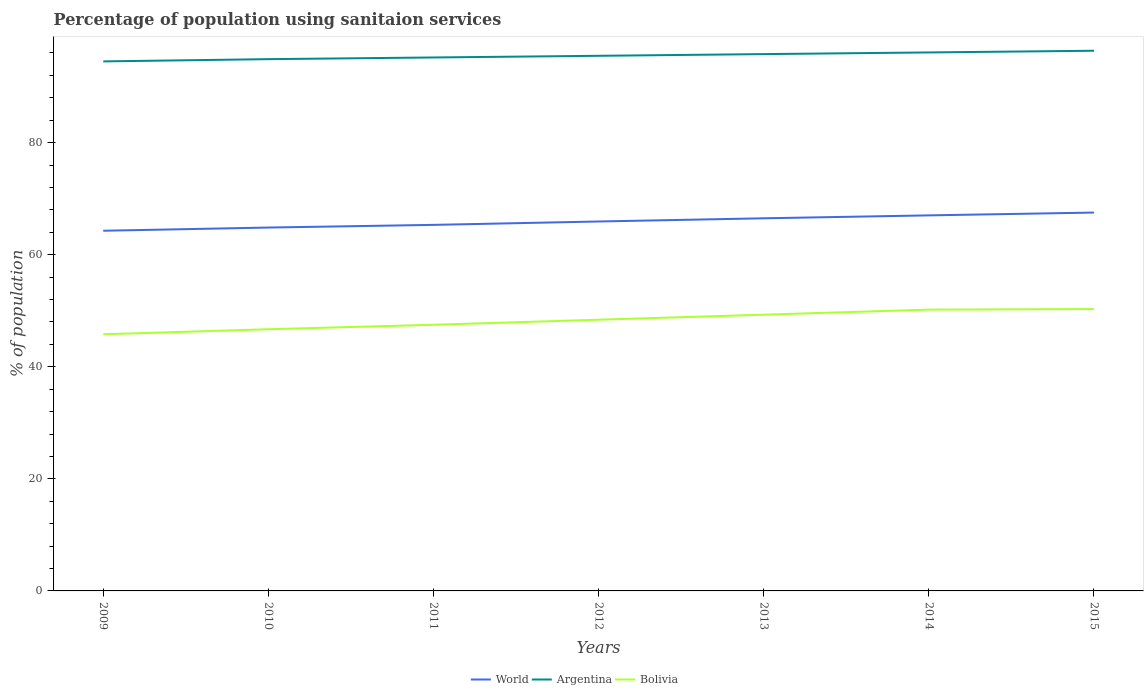How many different coloured lines are there?
Offer a very short reply. 3. Does the line corresponding to Bolivia intersect with the line corresponding to Argentina?
Your answer should be compact. No. Across all years, what is the maximum percentage of population using sanitaion services in Bolivia?
Offer a terse response. 45.8. In which year was the percentage of population using sanitaion services in Argentina maximum?
Offer a very short reply. 2009. What is the total percentage of population using sanitaion services in World in the graph?
Keep it short and to the point. -0.57. What is the difference between the highest and the second highest percentage of population using sanitaion services in World?
Your answer should be very brief. 3.25. What is the difference between the highest and the lowest percentage of population using sanitaion services in World?
Provide a succinct answer. 4. Are the values on the major ticks of Y-axis written in scientific E-notation?
Ensure brevity in your answer.  No. Does the graph contain any zero values?
Your response must be concise. No. Does the graph contain grids?
Give a very brief answer. No. How many legend labels are there?
Make the answer very short. 3. What is the title of the graph?
Your answer should be compact. Percentage of population using sanitaion services. Does "Tajikistan" appear as one of the legend labels in the graph?
Give a very brief answer. No. What is the label or title of the Y-axis?
Your answer should be compact. % of population. What is the % of population of World in 2009?
Offer a very short reply. 64.28. What is the % of population of Argentina in 2009?
Offer a terse response. 94.5. What is the % of population of Bolivia in 2009?
Make the answer very short. 45.8. What is the % of population in World in 2010?
Give a very brief answer. 64.85. What is the % of population in Argentina in 2010?
Keep it short and to the point. 94.9. What is the % of population in Bolivia in 2010?
Your response must be concise. 46.7. What is the % of population in World in 2011?
Your answer should be very brief. 65.33. What is the % of population of Argentina in 2011?
Keep it short and to the point. 95.2. What is the % of population of Bolivia in 2011?
Offer a very short reply. 47.5. What is the % of population of World in 2012?
Keep it short and to the point. 65.93. What is the % of population in Argentina in 2012?
Offer a very short reply. 95.5. What is the % of population in Bolivia in 2012?
Offer a terse response. 48.4. What is the % of population of World in 2013?
Provide a succinct answer. 66.5. What is the % of population in Argentina in 2013?
Provide a short and direct response. 95.8. What is the % of population of Bolivia in 2013?
Keep it short and to the point. 49.3. What is the % of population of World in 2014?
Your answer should be very brief. 67.02. What is the % of population in Argentina in 2014?
Your answer should be very brief. 96.1. What is the % of population in Bolivia in 2014?
Your answer should be very brief. 50.2. What is the % of population in World in 2015?
Make the answer very short. 67.52. What is the % of population of Argentina in 2015?
Offer a terse response. 96.4. What is the % of population of Bolivia in 2015?
Your answer should be very brief. 50.3. Across all years, what is the maximum % of population of World?
Give a very brief answer. 67.52. Across all years, what is the maximum % of population of Argentina?
Give a very brief answer. 96.4. Across all years, what is the maximum % of population in Bolivia?
Your response must be concise. 50.3. Across all years, what is the minimum % of population in World?
Keep it short and to the point. 64.28. Across all years, what is the minimum % of population of Argentina?
Offer a terse response. 94.5. Across all years, what is the minimum % of population in Bolivia?
Provide a short and direct response. 45.8. What is the total % of population of World in the graph?
Ensure brevity in your answer.  461.43. What is the total % of population in Argentina in the graph?
Your response must be concise. 668.4. What is the total % of population of Bolivia in the graph?
Give a very brief answer. 338.2. What is the difference between the % of population of World in 2009 and that in 2010?
Your answer should be compact. -0.57. What is the difference between the % of population of Bolivia in 2009 and that in 2010?
Give a very brief answer. -0.9. What is the difference between the % of population of World in 2009 and that in 2011?
Keep it short and to the point. -1.05. What is the difference between the % of population in World in 2009 and that in 2012?
Your response must be concise. -1.65. What is the difference between the % of population of Argentina in 2009 and that in 2012?
Ensure brevity in your answer.  -1. What is the difference between the % of population in World in 2009 and that in 2013?
Provide a succinct answer. -2.22. What is the difference between the % of population of World in 2009 and that in 2014?
Offer a terse response. -2.74. What is the difference between the % of population of Argentina in 2009 and that in 2014?
Your answer should be compact. -1.6. What is the difference between the % of population in World in 2009 and that in 2015?
Give a very brief answer. -3.25. What is the difference between the % of population of Argentina in 2009 and that in 2015?
Make the answer very short. -1.9. What is the difference between the % of population of World in 2010 and that in 2011?
Your answer should be compact. -0.48. What is the difference between the % of population in Argentina in 2010 and that in 2011?
Provide a succinct answer. -0.3. What is the difference between the % of population in World in 2010 and that in 2012?
Your answer should be compact. -1.08. What is the difference between the % of population of Argentina in 2010 and that in 2012?
Provide a short and direct response. -0.6. What is the difference between the % of population in Bolivia in 2010 and that in 2012?
Give a very brief answer. -1.7. What is the difference between the % of population in World in 2010 and that in 2013?
Your response must be concise. -1.65. What is the difference between the % of population in World in 2010 and that in 2014?
Your answer should be very brief. -2.17. What is the difference between the % of population in Argentina in 2010 and that in 2014?
Keep it short and to the point. -1.2. What is the difference between the % of population of Bolivia in 2010 and that in 2014?
Keep it short and to the point. -3.5. What is the difference between the % of population in World in 2010 and that in 2015?
Your response must be concise. -2.67. What is the difference between the % of population in Bolivia in 2010 and that in 2015?
Provide a short and direct response. -3.6. What is the difference between the % of population of World in 2011 and that in 2012?
Offer a very short reply. -0.6. What is the difference between the % of population in Bolivia in 2011 and that in 2012?
Make the answer very short. -0.9. What is the difference between the % of population of World in 2011 and that in 2013?
Keep it short and to the point. -1.17. What is the difference between the % of population of Argentina in 2011 and that in 2013?
Offer a very short reply. -0.6. What is the difference between the % of population of World in 2011 and that in 2014?
Provide a succinct answer. -1.7. What is the difference between the % of population of World in 2011 and that in 2015?
Your answer should be very brief. -2.2. What is the difference between the % of population in World in 2012 and that in 2013?
Give a very brief answer. -0.57. What is the difference between the % of population in Argentina in 2012 and that in 2013?
Give a very brief answer. -0.3. What is the difference between the % of population in Bolivia in 2012 and that in 2013?
Offer a terse response. -0.9. What is the difference between the % of population of World in 2012 and that in 2014?
Your answer should be compact. -1.09. What is the difference between the % of population of Argentina in 2012 and that in 2014?
Offer a very short reply. -0.6. What is the difference between the % of population in Bolivia in 2012 and that in 2014?
Offer a terse response. -1.8. What is the difference between the % of population of World in 2012 and that in 2015?
Provide a succinct answer. -1.59. What is the difference between the % of population in Argentina in 2012 and that in 2015?
Ensure brevity in your answer.  -0.9. What is the difference between the % of population of Bolivia in 2012 and that in 2015?
Offer a very short reply. -1.9. What is the difference between the % of population in World in 2013 and that in 2014?
Your response must be concise. -0.52. What is the difference between the % of population in World in 2013 and that in 2015?
Make the answer very short. -1.02. What is the difference between the % of population in Argentina in 2013 and that in 2015?
Offer a very short reply. -0.6. What is the difference between the % of population of World in 2014 and that in 2015?
Offer a very short reply. -0.5. What is the difference between the % of population of Bolivia in 2014 and that in 2015?
Make the answer very short. -0.1. What is the difference between the % of population in World in 2009 and the % of population in Argentina in 2010?
Your response must be concise. -30.62. What is the difference between the % of population in World in 2009 and the % of population in Bolivia in 2010?
Keep it short and to the point. 17.58. What is the difference between the % of population in Argentina in 2009 and the % of population in Bolivia in 2010?
Keep it short and to the point. 47.8. What is the difference between the % of population of World in 2009 and the % of population of Argentina in 2011?
Your answer should be compact. -30.92. What is the difference between the % of population in World in 2009 and the % of population in Bolivia in 2011?
Provide a succinct answer. 16.78. What is the difference between the % of population in Argentina in 2009 and the % of population in Bolivia in 2011?
Provide a succinct answer. 47. What is the difference between the % of population of World in 2009 and the % of population of Argentina in 2012?
Provide a succinct answer. -31.22. What is the difference between the % of population of World in 2009 and the % of population of Bolivia in 2012?
Offer a very short reply. 15.88. What is the difference between the % of population of Argentina in 2009 and the % of population of Bolivia in 2012?
Offer a terse response. 46.1. What is the difference between the % of population of World in 2009 and the % of population of Argentina in 2013?
Your response must be concise. -31.52. What is the difference between the % of population in World in 2009 and the % of population in Bolivia in 2013?
Offer a terse response. 14.98. What is the difference between the % of population of Argentina in 2009 and the % of population of Bolivia in 2013?
Ensure brevity in your answer.  45.2. What is the difference between the % of population of World in 2009 and the % of population of Argentina in 2014?
Provide a succinct answer. -31.82. What is the difference between the % of population in World in 2009 and the % of population in Bolivia in 2014?
Make the answer very short. 14.08. What is the difference between the % of population of Argentina in 2009 and the % of population of Bolivia in 2014?
Make the answer very short. 44.3. What is the difference between the % of population in World in 2009 and the % of population in Argentina in 2015?
Provide a succinct answer. -32.12. What is the difference between the % of population in World in 2009 and the % of population in Bolivia in 2015?
Provide a short and direct response. 13.98. What is the difference between the % of population of Argentina in 2009 and the % of population of Bolivia in 2015?
Your response must be concise. 44.2. What is the difference between the % of population in World in 2010 and the % of population in Argentina in 2011?
Ensure brevity in your answer.  -30.35. What is the difference between the % of population of World in 2010 and the % of population of Bolivia in 2011?
Give a very brief answer. 17.35. What is the difference between the % of population of Argentina in 2010 and the % of population of Bolivia in 2011?
Offer a very short reply. 47.4. What is the difference between the % of population of World in 2010 and the % of population of Argentina in 2012?
Give a very brief answer. -30.65. What is the difference between the % of population of World in 2010 and the % of population of Bolivia in 2012?
Your answer should be compact. 16.45. What is the difference between the % of population in Argentina in 2010 and the % of population in Bolivia in 2012?
Give a very brief answer. 46.5. What is the difference between the % of population in World in 2010 and the % of population in Argentina in 2013?
Keep it short and to the point. -30.95. What is the difference between the % of population in World in 2010 and the % of population in Bolivia in 2013?
Make the answer very short. 15.55. What is the difference between the % of population in Argentina in 2010 and the % of population in Bolivia in 2013?
Your answer should be very brief. 45.6. What is the difference between the % of population of World in 2010 and the % of population of Argentina in 2014?
Provide a short and direct response. -31.25. What is the difference between the % of population in World in 2010 and the % of population in Bolivia in 2014?
Offer a terse response. 14.65. What is the difference between the % of population in Argentina in 2010 and the % of population in Bolivia in 2014?
Give a very brief answer. 44.7. What is the difference between the % of population in World in 2010 and the % of population in Argentina in 2015?
Offer a terse response. -31.55. What is the difference between the % of population in World in 2010 and the % of population in Bolivia in 2015?
Keep it short and to the point. 14.55. What is the difference between the % of population of Argentina in 2010 and the % of population of Bolivia in 2015?
Your answer should be very brief. 44.6. What is the difference between the % of population of World in 2011 and the % of population of Argentina in 2012?
Offer a very short reply. -30.17. What is the difference between the % of population of World in 2011 and the % of population of Bolivia in 2012?
Offer a very short reply. 16.93. What is the difference between the % of population of Argentina in 2011 and the % of population of Bolivia in 2012?
Your answer should be very brief. 46.8. What is the difference between the % of population of World in 2011 and the % of population of Argentina in 2013?
Provide a short and direct response. -30.47. What is the difference between the % of population in World in 2011 and the % of population in Bolivia in 2013?
Make the answer very short. 16.03. What is the difference between the % of population in Argentina in 2011 and the % of population in Bolivia in 2013?
Make the answer very short. 45.9. What is the difference between the % of population of World in 2011 and the % of population of Argentina in 2014?
Your answer should be compact. -30.77. What is the difference between the % of population of World in 2011 and the % of population of Bolivia in 2014?
Your answer should be compact. 15.13. What is the difference between the % of population in World in 2011 and the % of population in Argentina in 2015?
Give a very brief answer. -31.07. What is the difference between the % of population of World in 2011 and the % of population of Bolivia in 2015?
Offer a very short reply. 15.03. What is the difference between the % of population in Argentina in 2011 and the % of population in Bolivia in 2015?
Provide a short and direct response. 44.9. What is the difference between the % of population in World in 2012 and the % of population in Argentina in 2013?
Your answer should be very brief. -29.87. What is the difference between the % of population of World in 2012 and the % of population of Bolivia in 2013?
Your response must be concise. 16.63. What is the difference between the % of population of Argentina in 2012 and the % of population of Bolivia in 2013?
Give a very brief answer. 46.2. What is the difference between the % of population of World in 2012 and the % of population of Argentina in 2014?
Provide a succinct answer. -30.17. What is the difference between the % of population of World in 2012 and the % of population of Bolivia in 2014?
Provide a succinct answer. 15.73. What is the difference between the % of population of Argentina in 2012 and the % of population of Bolivia in 2014?
Your answer should be very brief. 45.3. What is the difference between the % of population in World in 2012 and the % of population in Argentina in 2015?
Offer a terse response. -30.47. What is the difference between the % of population in World in 2012 and the % of population in Bolivia in 2015?
Provide a short and direct response. 15.63. What is the difference between the % of population of Argentina in 2012 and the % of population of Bolivia in 2015?
Your answer should be very brief. 45.2. What is the difference between the % of population in World in 2013 and the % of population in Argentina in 2014?
Your response must be concise. -29.6. What is the difference between the % of population of World in 2013 and the % of population of Bolivia in 2014?
Provide a short and direct response. 16.3. What is the difference between the % of population in Argentina in 2013 and the % of population in Bolivia in 2014?
Provide a succinct answer. 45.6. What is the difference between the % of population of World in 2013 and the % of population of Argentina in 2015?
Give a very brief answer. -29.9. What is the difference between the % of population of World in 2013 and the % of population of Bolivia in 2015?
Provide a short and direct response. 16.2. What is the difference between the % of population of Argentina in 2013 and the % of population of Bolivia in 2015?
Keep it short and to the point. 45.5. What is the difference between the % of population in World in 2014 and the % of population in Argentina in 2015?
Offer a terse response. -29.38. What is the difference between the % of population in World in 2014 and the % of population in Bolivia in 2015?
Your answer should be very brief. 16.72. What is the difference between the % of population in Argentina in 2014 and the % of population in Bolivia in 2015?
Ensure brevity in your answer.  45.8. What is the average % of population in World per year?
Your answer should be compact. 65.92. What is the average % of population of Argentina per year?
Provide a succinct answer. 95.49. What is the average % of population of Bolivia per year?
Give a very brief answer. 48.31. In the year 2009, what is the difference between the % of population in World and % of population in Argentina?
Give a very brief answer. -30.22. In the year 2009, what is the difference between the % of population in World and % of population in Bolivia?
Ensure brevity in your answer.  18.48. In the year 2009, what is the difference between the % of population in Argentina and % of population in Bolivia?
Give a very brief answer. 48.7. In the year 2010, what is the difference between the % of population in World and % of population in Argentina?
Provide a succinct answer. -30.05. In the year 2010, what is the difference between the % of population in World and % of population in Bolivia?
Give a very brief answer. 18.15. In the year 2010, what is the difference between the % of population of Argentina and % of population of Bolivia?
Your response must be concise. 48.2. In the year 2011, what is the difference between the % of population of World and % of population of Argentina?
Make the answer very short. -29.87. In the year 2011, what is the difference between the % of population of World and % of population of Bolivia?
Your answer should be very brief. 17.83. In the year 2011, what is the difference between the % of population of Argentina and % of population of Bolivia?
Provide a short and direct response. 47.7. In the year 2012, what is the difference between the % of population of World and % of population of Argentina?
Make the answer very short. -29.57. In the year 2012, what is the difference between the % of population in World and % of population in Bolivia?
Your response must be concise. 17.53. In the year 2012, what is the difference between the % of population in Argentina and % of population in Bolivia?
Provide a short and direct response. 47.1. In the year 2013, what is the difference between the % of population in World and % of population in Argentina?
Keep it short and to the point. -29.3. In the year 2013, what is the difference between the % of population of World and % of population of Bolivia?
Your response must be concise. 17.2. In the year 2013, what is the difference between the % of population in Argentina and % of population in Bolivia?
Make the answer very short. 46.5. In the year 2014, what is the difference between the % of population of World and % of population of Argentina?
Give a very brief answer. -29.08. In the year 2014, what is the difference between the % of population of World and % of population of Bolivia?
Ensure brevity in your answer.  16.82. In the year 2014, what is the difference between the % of population in Argentina and % of population in Bolivia?
Offer a very short reply. 45.9. In the year 2015, what is the difference between the % of population in World and % of population in Argentina?
Offer a terse response. -28.88. In the year 2015, what is the difference between the % of population of World and % of population of Bolivia?
Offer a very short reply. 17.22. In the year 2015, what is the difference between the % of population of Argentina and % of population of Bolivia?
Offer a terse response. 46.1. What is the ratio of the % of population of World in 2009 to that in 2010?
Offer a very short reply. 0.99. What is the ratio of the % of population in Argentina in 2009 to that in 2010?
Provide a short and direct response. 1. What is the ratio of the % of population of Bolivia in 2009 to that in 2010?
Your response must be concise. 0.98. What is the ratio of the % of population in Bolivia in 2009 to that in 2011?
Provide a short and direct response. 0.96. What is the ratio of the % of population in World in 2009 to that in 2012?
Make the answer very short. 0.97. What is the ratio of the % of population of Argentina in 2009 to that in 2012?
Offer a very short reply. 0.99. What is the ratio of the % of population in Bolivia in 2009 to that in 2012?
Your answer should be compact. 0.95. What is the ratio of the % of population of World in 2009 to that in 2013?
Give a very brief answer. 0.97. What is the ratio of the % of population of Argentina in 2009 to that in 2013?
Offer a very short reply. 0.99. What is the ratio of the % of population of Bolivia in 2009 to that in 2013?
Provide a short and direct response. 0.93. What is the ratio of the % of population in World in 2009 to that in 2014?
Make the answer very short. 0.96. What is the ratio of the % of population of Argentina in 2009 to that in 2014?
Make the answer very short. 0.98. What is the ratio of the % of population of Bolivia in 2009 to that in 2014?
Give a very brief answer. 0.91. What is the ratio of the % of population in World in 2009 to that in 2015?
Offer a very short reply. 0.95. What is the ratio of the % of population in Argentina in 2009 to that in 2015?
Provide a succinct answer. 0.98. What is the ratio of the % of population in Bolivia in 2009 to that in 2015?
Provide a short and direct response. 0.91. What is the ratio of the % of population in Argentina in 2010 to that in 2011?
Offer a terse response. 1. What is the ratio of the % of population of Bolivia in 2010 to that in 2011?
Give a very brief answer. 0.98. What is the ratio of the % of population in World in 2010 to that in 2012?
Provide a succinct answer. 0.98. What is the ratio of the % of population in Bolivia in 2010 to that in 2012?
Provide a short and direct response. 0.96. What is the ratio of the % of population in World in 2010 to that in 2013?
Provide a succinct answer. 0.98. What is the ratio of the % of population of Argentina in 2010 to that in 2013?
Provide a succinct answer. 0.99. What is the ratio of the % of population of Bolivia in 2010 to that in 2013?
Your answer should be compact. 0.95. What is the ratio of the % of population of World in 2010 to that in 2014?
Ensure brevity in your answer.  0.97. What is the ratio of the % of population of Argentina in 2010 to that in 2014?
Your response must be concise. 0.99. What is the ratio of the % of population of Bolivia in 2010 to that in 2014?
Your answer should be very brief. 0.93. What is the ratio of the % of population in World in 2010 to that in 2015?
Your answer should be very brief. 0.96. What is the ratio of the % of population of Argentina in 2010 to that in 2015?
Your answer should be compact. 0.98. What is the ratio of the % of population in Bolivia in 2010 to that in 2015?
Ensure brevity in your answer.  0.93. What is the ratio of the % of population in Argentina in 2011 to that in 2012?
Your answer should be compact. 1. What is the ratio of the % of population of Bolivia in 2011 to that in 2012?
Give a very brief answer. 0.98. What is the ratio of the % of population of World in 2011 to that in 2013?
Offer a terse response. 0.98. What is the ratio of the % of population of Bolivia in 2011 to that in 2013?
Keep it short and to the point. 0.96. What is the ratio of the % of population of World in 2011 to that in 2014?
Your answer should be compact. 0.97. What is the ratio of the % of population of Argentina in 2011 to that in 2014?
Make the answer very short. 0.99. What is the ratio of the % of population in Bolivia in 2011 to that in 2014?
Make the answer very short. 0.95. What is the ratio of the % of population in World in 2011 to that in 2015?
Your answer should be very brief. 0.97. What is the ratio of the % of population of Argentina in 2011 to that in 2015?
Provide a short and direct response. 0.99. What is the ratio of the % of population of Bolivia in 2011 to that in 2015?
Make the answer very short. 0.94. What is the ratio of the % of population in World in 2012 to that in 2013?
Provide a succinct answer. 0.99. What is the ratio of the % of population in Bolivia in 2012 to that in 2013?
Your answer should be very brief. 0.98. What is the ratio of the % of population of World in 2012 to that in 2014?
Make the answer very short. 0.98. What is the ratio of the % of population of Argentina in 2012 to that in 2014?
Your response must be concise. 0.99. What is the ratio of the % of population in Bolivia in 2012 to that in 2014?
Offer a terse response. 0.96. What is the ratio of the % of population in World in 2012 to that in 2015?
Your answer should be compact. 0.98. What is the ratio of the % of population of Argentina in 2012 to that in 2015?
Keep it short and to the point. 0.99. What is the ratio of the % of population of Bolivia in 2012 to that in 2015?
Your response must be concise. 0.96. What is the ratio of the % of population of Bolivia in 2013 to that in 2014?
Make the answer very short. 0.98. What is the ratio of the % of population in Argentina in 2013 to that in 2015?
Ensure brevity in your answer.  0.99. What is the ratio of the % of population of Bolivia in 2013 to that in 2015?
Keep it short and to the point. 0.98. What is the ratio of the % of population of Argentina in 2014 to that in 2015?
Give a very brief answer. 1. What is the difference between the highest and the second highest % of population of World?
Your answer should be very brief. 0.5. What is the difference between the highest and the second highest % of population of Bolivia?
Your response must be concise. 0.1. What is the difference between the highest and the lowest % of population of World?
Provide a succinct answer. 3.25. What is the difference between the highest and the lowest % of population in Argentina?
Make the answer very short. 1.9. What is the difference between the highest and the lowest % of population of Bolivia?
Provide a short and direct response. 4.5. 